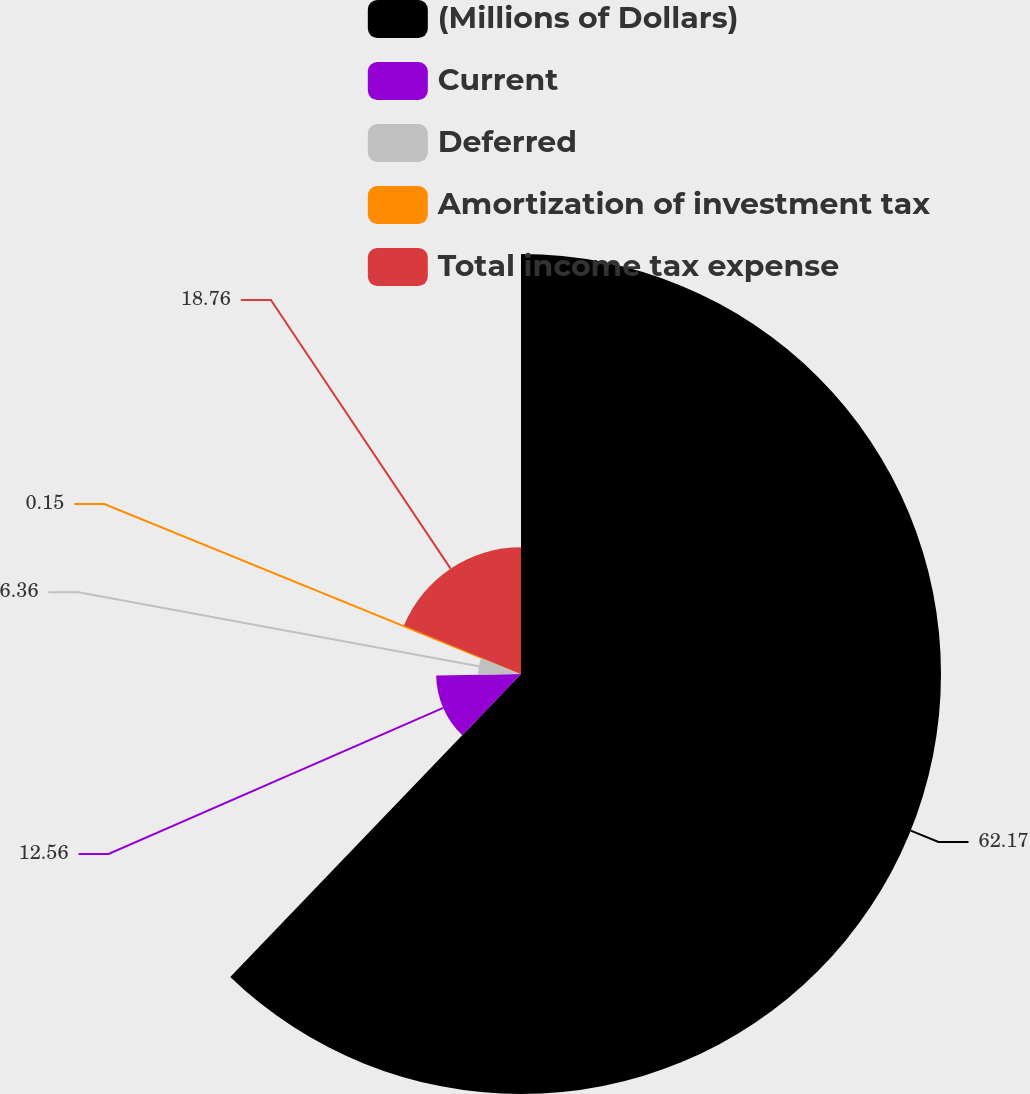Convert chart. <chart><loc_0><loc_0><loc_500><loc_500><pie_chart><fcel>(Millions of Dollars)<fcel>Current<fcel>Deferred<fcel>Amortization of investment tax<fcel>Total income tax expense<nl><fcel>62.17%<fcel>12.56%<fcel>6.36%<fcel>0.15%<fcel>18.76%<nl></chart> 